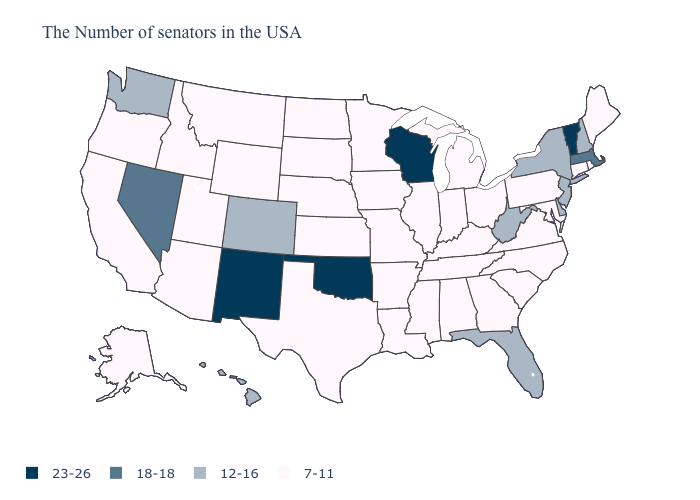What is the lowest value in the MidWest?
Keep it brief. 7-11. Which states have the highest value in the USA?
Answer briefly. Vermont, Wisconsin, Oklahoma, New Mexico. What is the lowest value in the USA?
Quick response, please. 7-11. What is the lowest value in states that border Maryland?
Quick response, please. 7-11. Which states have the lowest value in the West?
Keep it brief. Wyoming, Utah, Montana, Arizona, Idaho, California, Oregon, Alaska. Which states have the lowest value in the USA?
Give a very brief answer. Maine, Rhode Island, Connecticut, Maryland, Pennsylvania, Virginia, North Carolina, South Carolina, Ohio, Georgia, Michigan, Kentucky, Indiana, Alabama, Tennessee, Illinois, Mississippi, Louisiana, Missouri, Arkansas, Minnesota, Iowa, Kansas, Nebraska, Texas, South Dakota, North Dakota, Wyoming, Utah, Montana, Arizona, Idaho, California, Oregon, Alaska. What is the lowest value in the MidWest?
Give a very brief answer. 7-11. Name the states that have a value in the range 18-18?
Concise answer only. Massachusetts, Nevada. Name the states that have a value in the range 12-16?
Give a very brief answer. New Hampshire, New York, New Jersey, Delaware, West Virginia, Florida, Colorado, Washington, Hawaii. Which states hav the highest value in the South?
Give a very brief answer. Oklahoma. Among the states that border Utah , which have the lowest value?
Quick response, please. Wyoming, Arizona, Idaho. What is the lowest value in states that border Colorado?
Keep it brief. 7-11. Does Oklahoma have the highest value in the USA?
Answer briefly. Yes. Among the states that border Rhode Island , which have the lowest value?
Be succinct. Connecticut. What is the highest value in the USA?
Give a very brief answer. 23-26. 